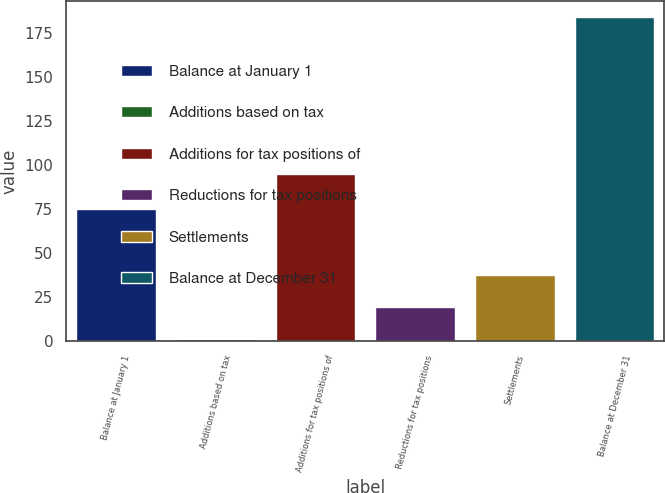Convert chart to OTSL. <chart><loc_0><loc_0><loc_500><loc_500><bar_chart><fcel>Balance at January 1<fcel>Additions based on tax<fcel>Additions for tax positions of<fcel>Reductions for tax positions<fcel>Settlements<fcel>Balance at December 31<nl><fcel>75<fcel>1<fcel>95<fcel>19.3<fcel>37.6<fcel>184<nl></chart> 